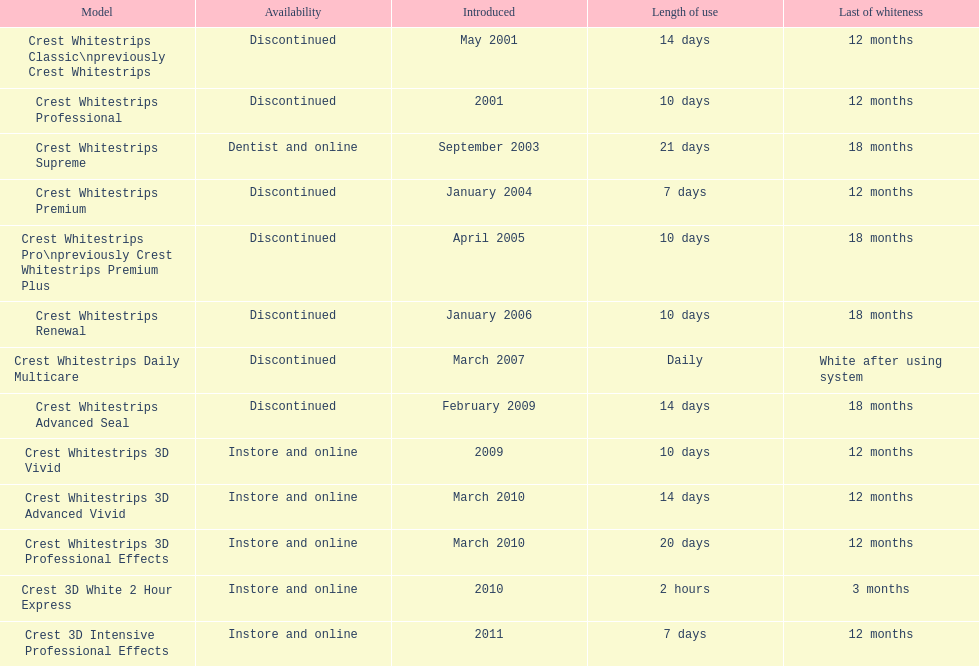How many items have been discontinued? 7. 